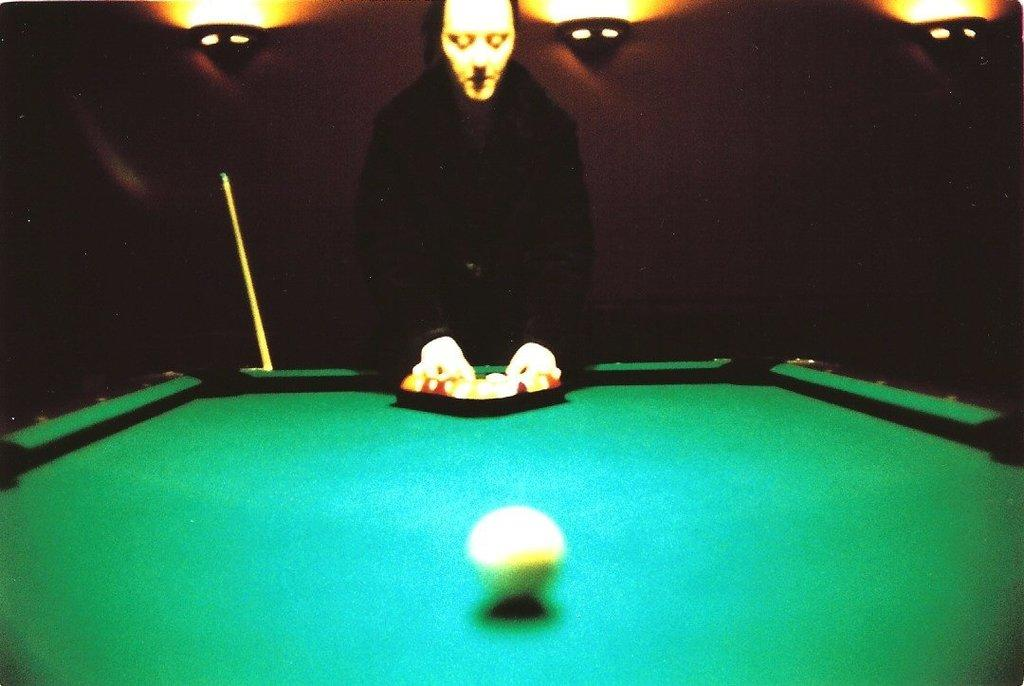What is the main subject in the foreground of the image? There is a person in the foreground of the image. What is the person doing in the image? The person is playing a game on a table. What can be seen in the background of the image? There is a curtain and lights in the background of the image. Where was the image taken? The image was taken in a hall. Is there a sink visible in the image? No, there is no sink present in the image. Can you see any dirt on the person playing the game? The image does not provide any information about dirt on the person playing the game. 